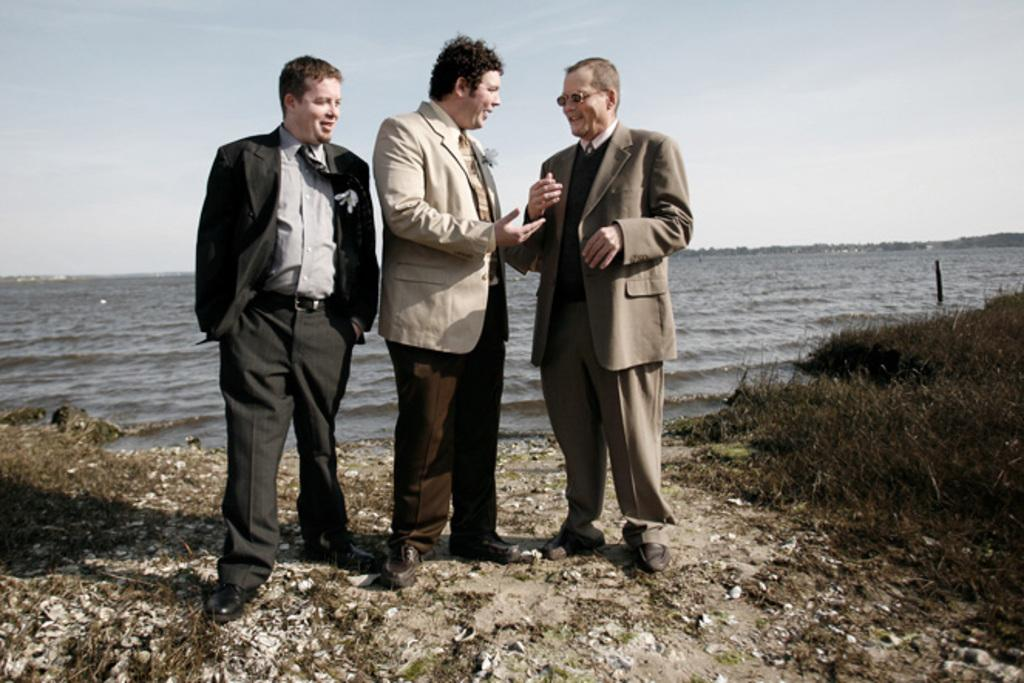Who is present in the image? There are men in the image. What expression do the men have? The men are smiling. What type of clothing are the men wearing? The men are wearing coats and ties. What is the ground made of in the image? There is grass on the ground in the image. What else can be seen in the image besides the men? There is water visible in the image. How would you describe the weather based on the image? The sky is cloudy in the image, suggesting overcast or potentially rainy weather. How many eggs are being held by the snake in the image? There is no snake or eggs present in the image. What is the relationship between the men and the brother mentioned in the image? There is no mention of a brother in the image, so it is not possible to determine their relationship. 